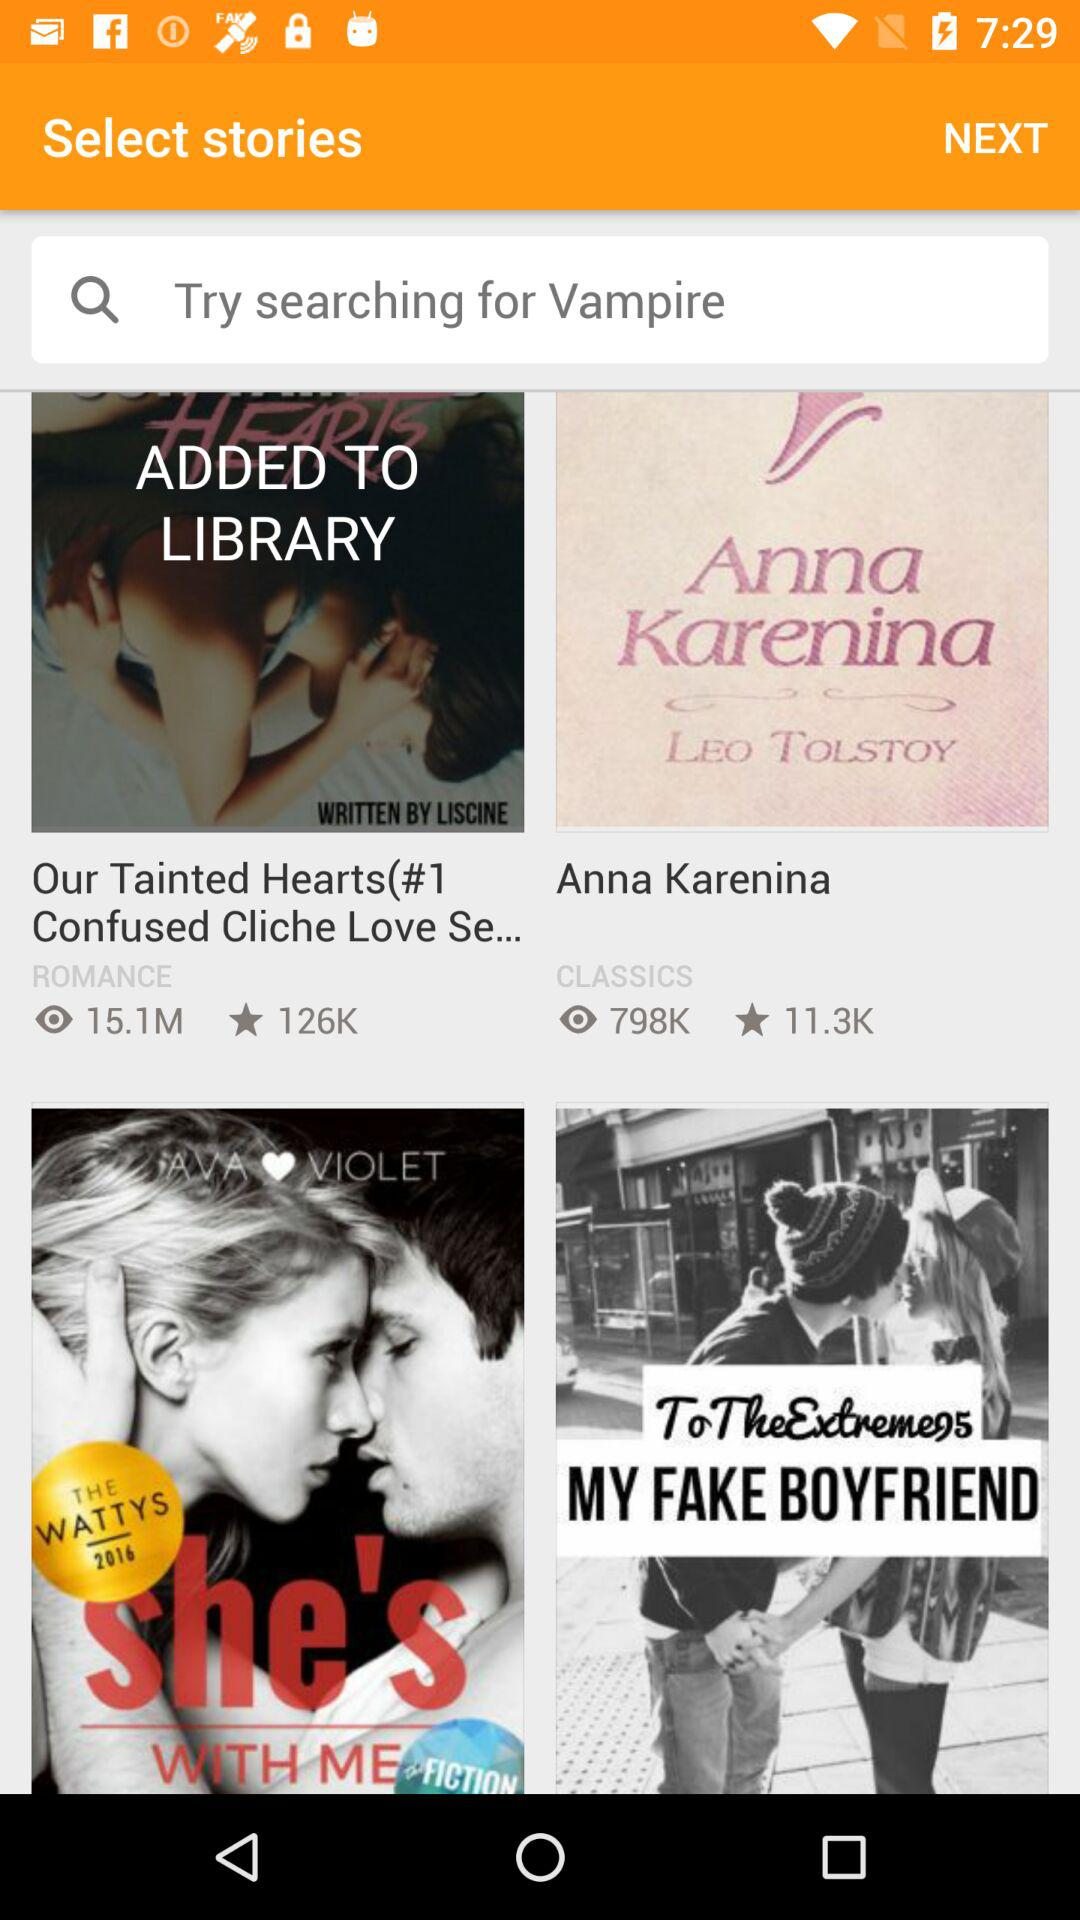What is the rating of our tainted hearts?
When the provided information is insufficient, respond with <no answer>. <no answer> 